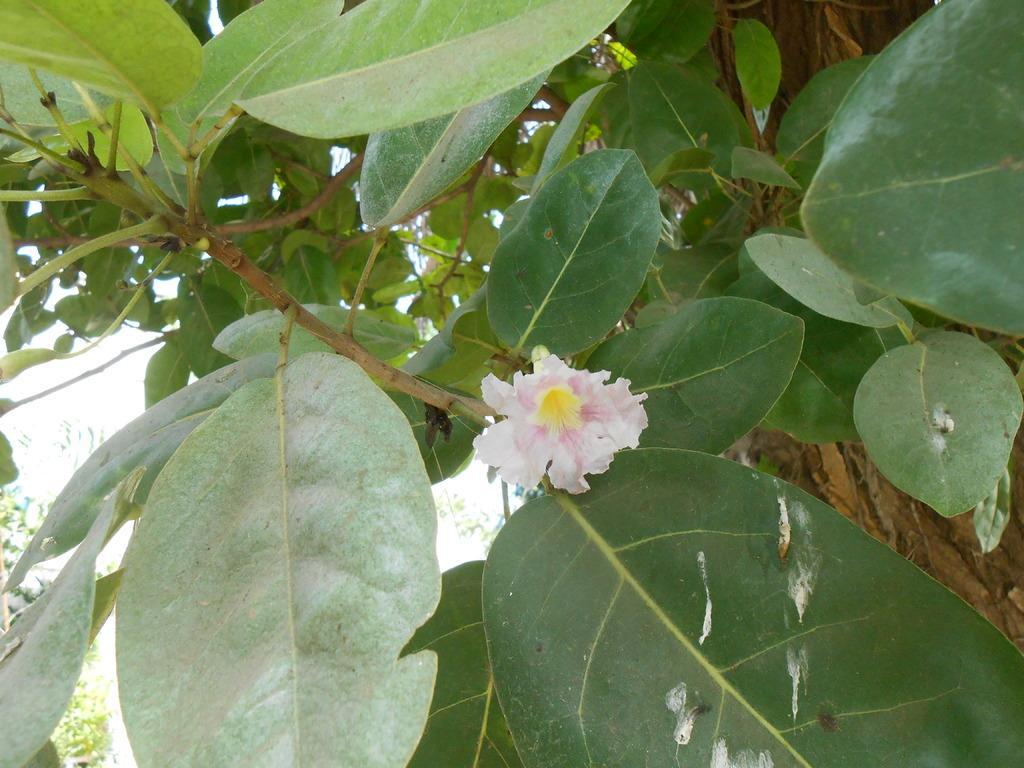Could you give a brief overview of what you see in this image? In the image there is a flower to the branch of a tree. 